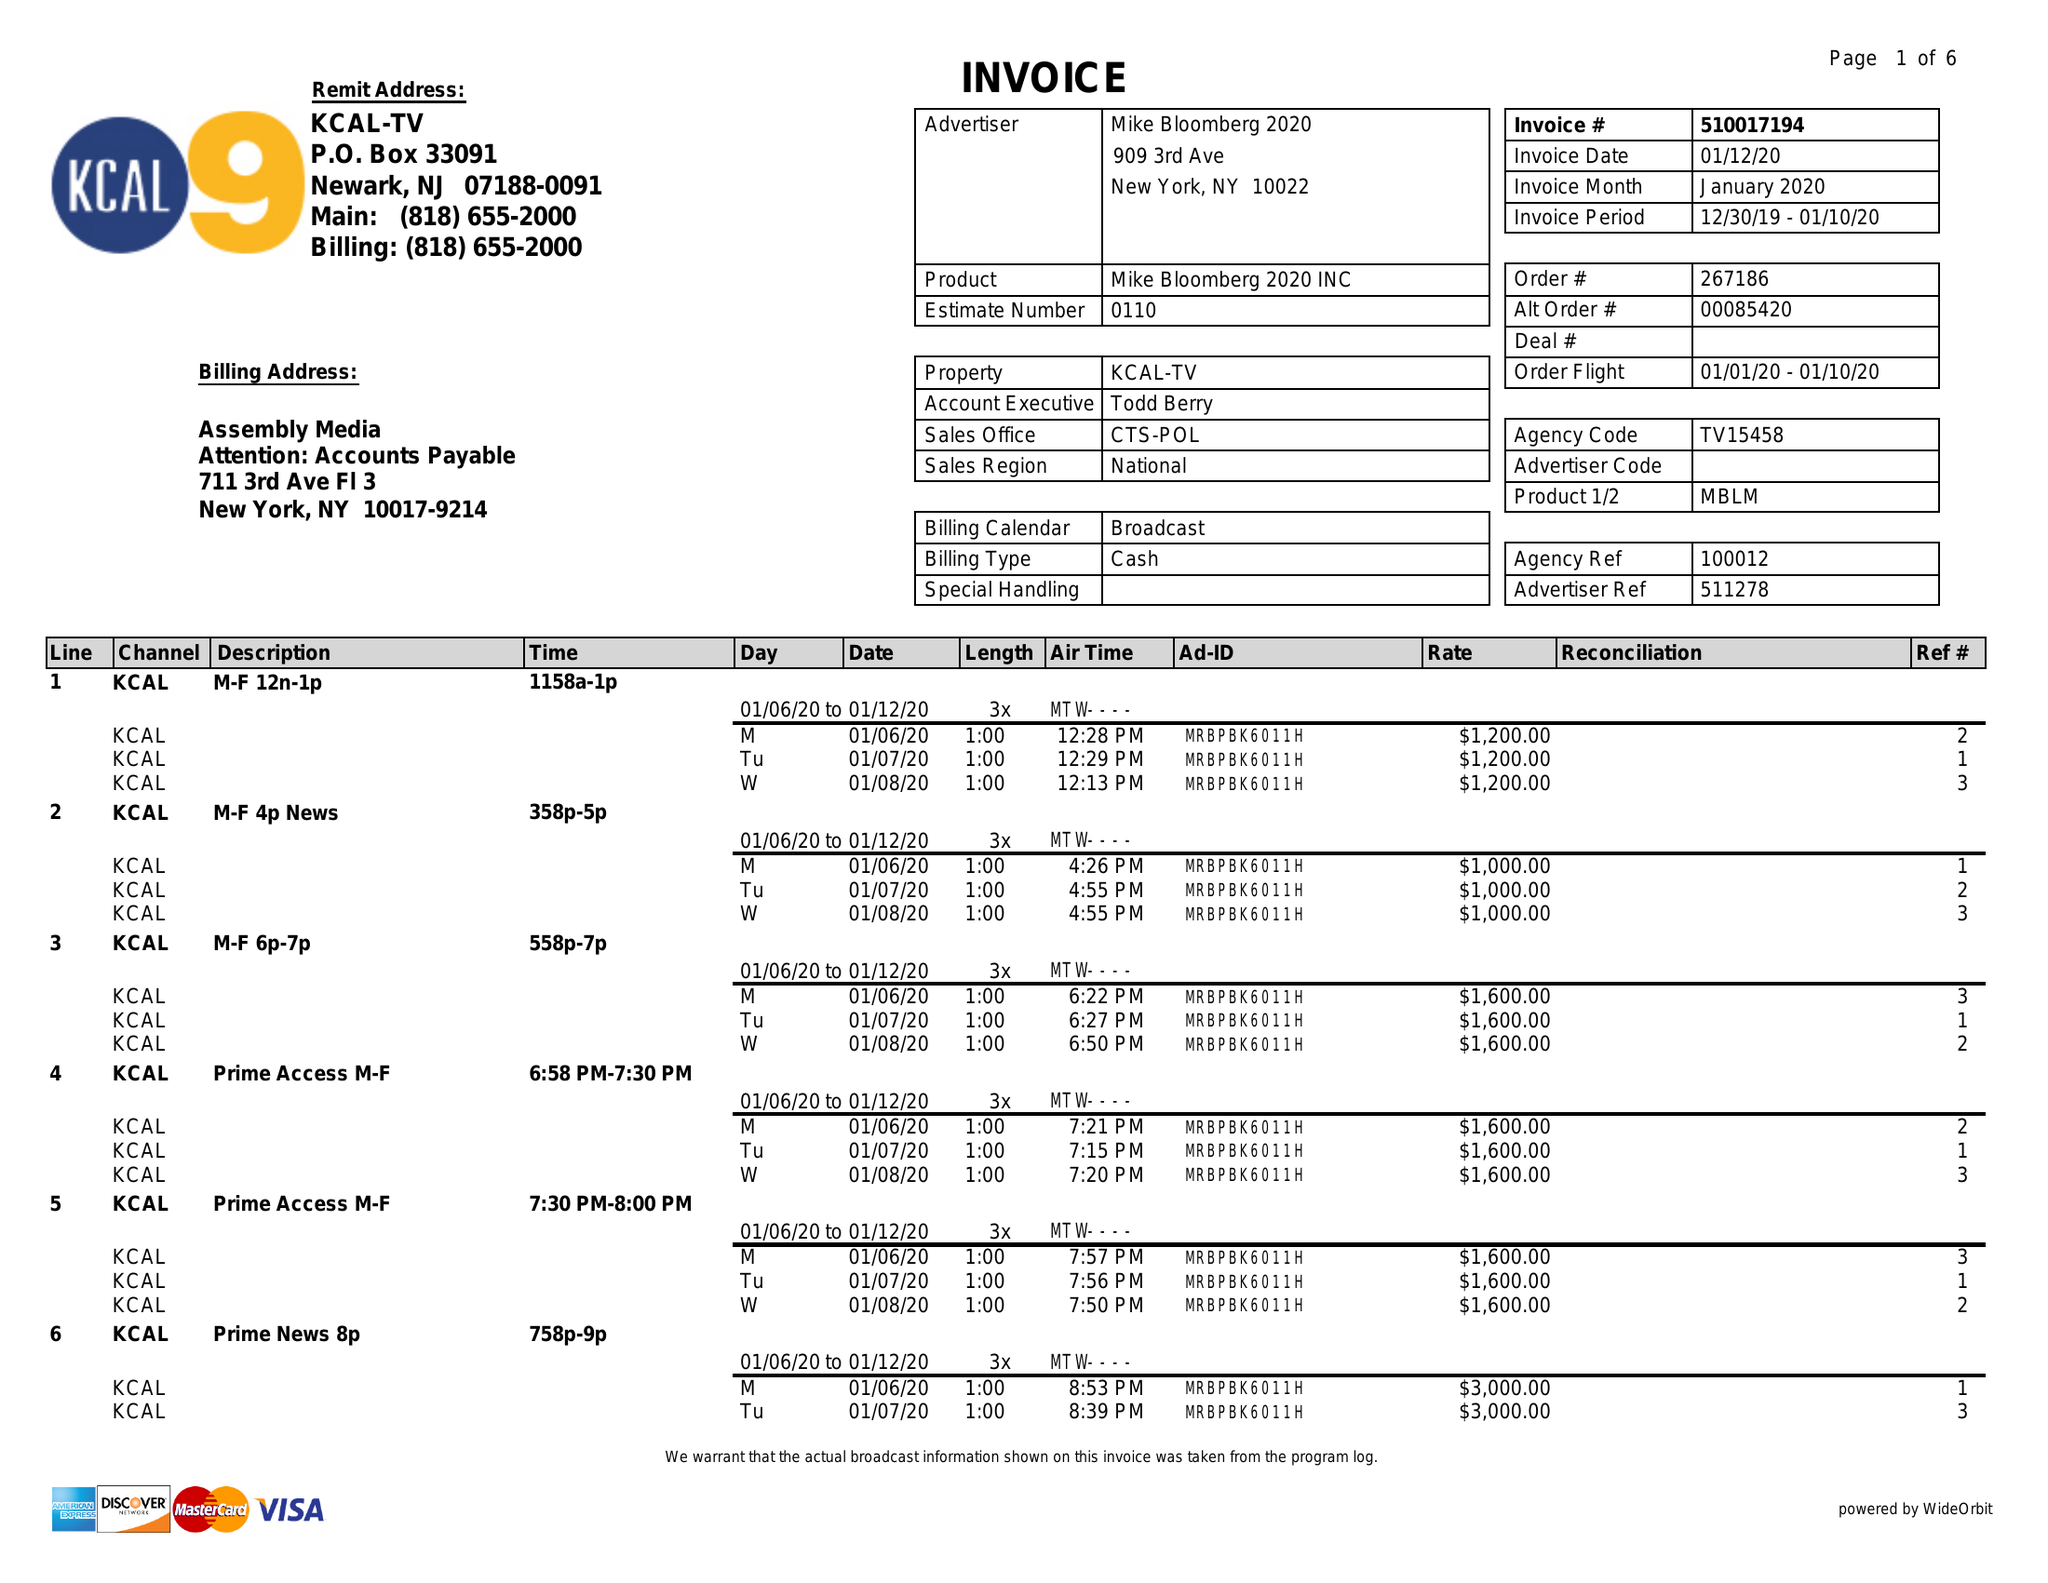What is the value for the gross_amount?
Answer the question using a single word or phrase. 142150.00 